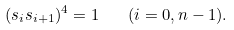<formula> <loc_0><loc_0><loc_500><loc_500>( s _ { i } s _ { i + 1 } ) ^ { 4 } = 1 \quad ( i = 0 , n - 1 ) .</formula> 